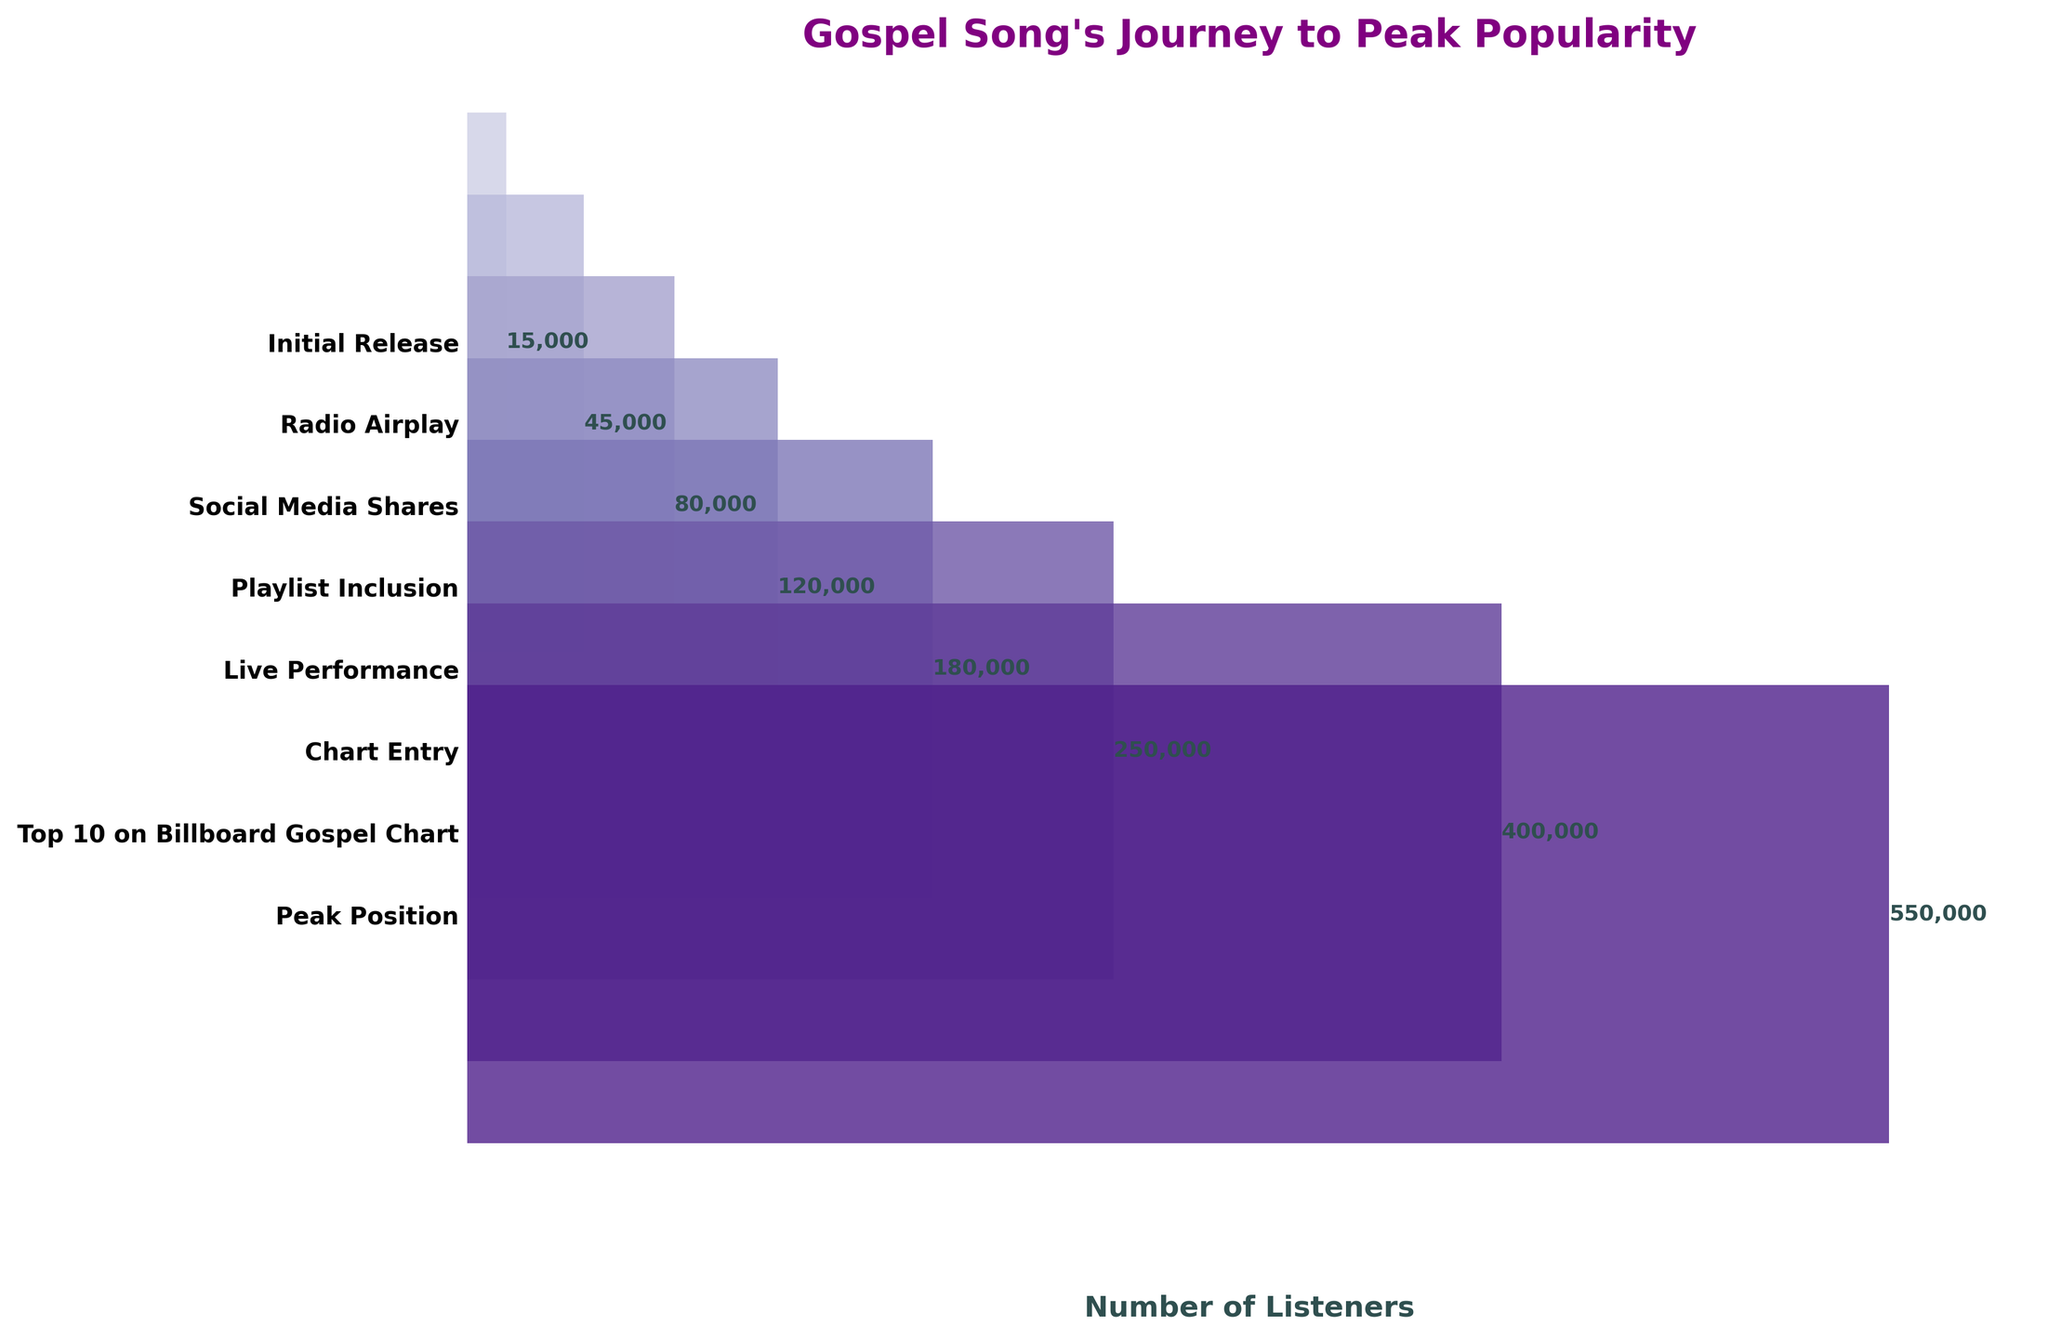How many listeners were there at the initial release stage? The chart lists "Initial Release" with the number of listeners beside it.
Answer: 15000 What is the main title of the figure? The title is written at the top of the figure in bold and colored font.
Answer: Gospel Song's Journey to Peak Popularity How many stages are shown in the chart? The stages are represented by bars with labels next to them along the y-axis. Count these labels to determine the number of stages.
Answer: 8 At which stage did the song hit 250,000 listeners? Look for the stage labeled with "250,000" listeners to identify the corresponding stage.
Answer: Chart Entry What's the peak number of listeners reached by the song? Locate the bar with the highest number of listeners, indicated at the right of the bar.
Answer: 550000 What is the difference in the number of listeners between the "Initial Release" and "Top 10 on Billboard Gospel Chart" stages? Subtract the number of listeners at "Initial Release" from the number at "Top 10 on Billboard Gospel Chart" (400,000 - 15,000).
Answer: 385000 Which stage had more listeners: "Live Performance" or "Playlist Inclusion"? Find the number of listeners for both stages and compare them.
Answer: Live Performance How many more listeners did the song gain from "Radio Airplay" to "Social Media Shares"? Subtract the number of listeners at "Radio Airplay" from "Social Media Shares" (80,000 - 45,000).
Answer: 35000 What was the immediate next stage after "Social Media Shares"? The next stage listed directly below "Social Media Shares" on the y-axis is the immediate next stage.
Answer: Playlist Inclusion What is the percentage increase in listeners from "Radio Airplay" to "Peak Position"? Calculate the percentage increase: ((550,000 - 45,000) / 45,000) * 100. The percentage represents the ratio of the increase to the original number of listeners.
Answer: 1122.22% 